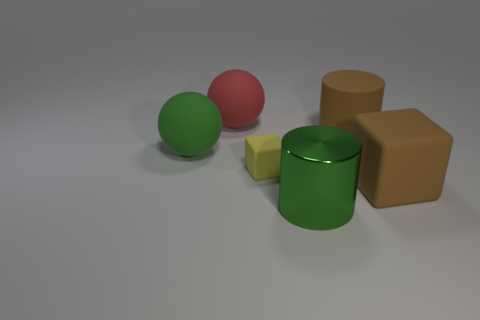Add 3 small matte things. How many objects exist? 9 Subtract all cubes. How many objects are left? 4 Add 5 tiny green shiny cubes. How many tiny green shiny cubes exist? 5 Subtract 0 gray balls. How many objects are left? 6 Subtract all large brown cylinders. Subtract all big rubber things. How many objects are left? 1 Add 4 large green shiny cylinders. How many large green shiny cylinders are left? 5 